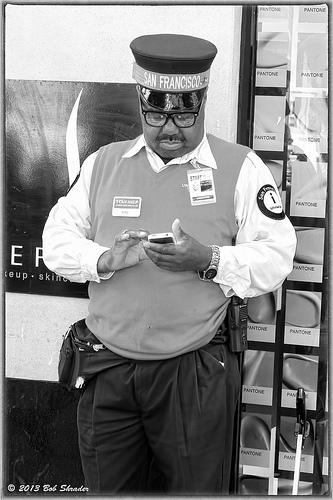Question: what does the man's hat say?
Choices:
A. San Francisco.
B. San Juan.
C. Los Angeles.
D. New York City.
Answer with the letter. Answer: A Question: what is the man holding?
Choices:
A. A phone.
B. A notebook.
C. A pen.
D. A credit card.
Answer with the letter. Answer: A Question: what word is repeated on the poster?
Choices:
A. Here.
B. Hello.
C. Pantone.
D. Welcome.
Answer with the letter. Answer: C Question: why is the man looking down?
Choices:
A. He dropped something.
B. He is counting his money.
C. He is buttoning his shirt.
D. To use the phone.
Answer with the letter. Answer: D Question: where was this picture taken?
Choices:
A. At a plane terminal.
B. At a bus terminal.
C. At a train station.
D. At a transit stop.
Answer with the letter. Answer: B Question: what is on the man's left wrist?
Choices:
A. Men's bracelet.
B. Medical ID.
C. Hospital tag.
D. A watch.
Answer with the letter. Answer: D Question: what is on the man's face?
Choices:
A. Glasses.
B. Sun glasses.
C. Suntan lotion.
D. Makeup.
Answer with the letter. Answer: A 